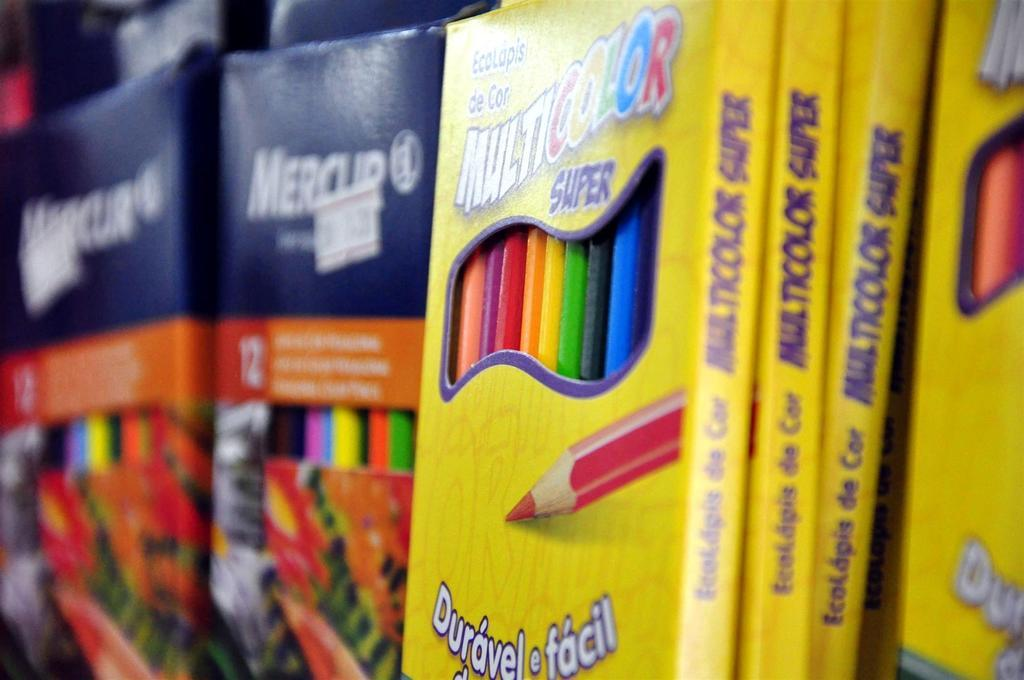<image>
Describe the image concisely. A shelf contains many boxes of colored pencils, with one brand marked EcoLapis de Cor. 